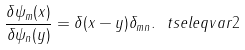Convert formula to latex. <formula><loc_0><loc_0><loc_500><loc_500>\frac { \delta \psi _ { m } ( x ) } { \delta \psi _ { n } ( y ) } = \delta ( x - y ) \delta _ { m n } . \ t s e l e q { v a r 2 }</formula> 